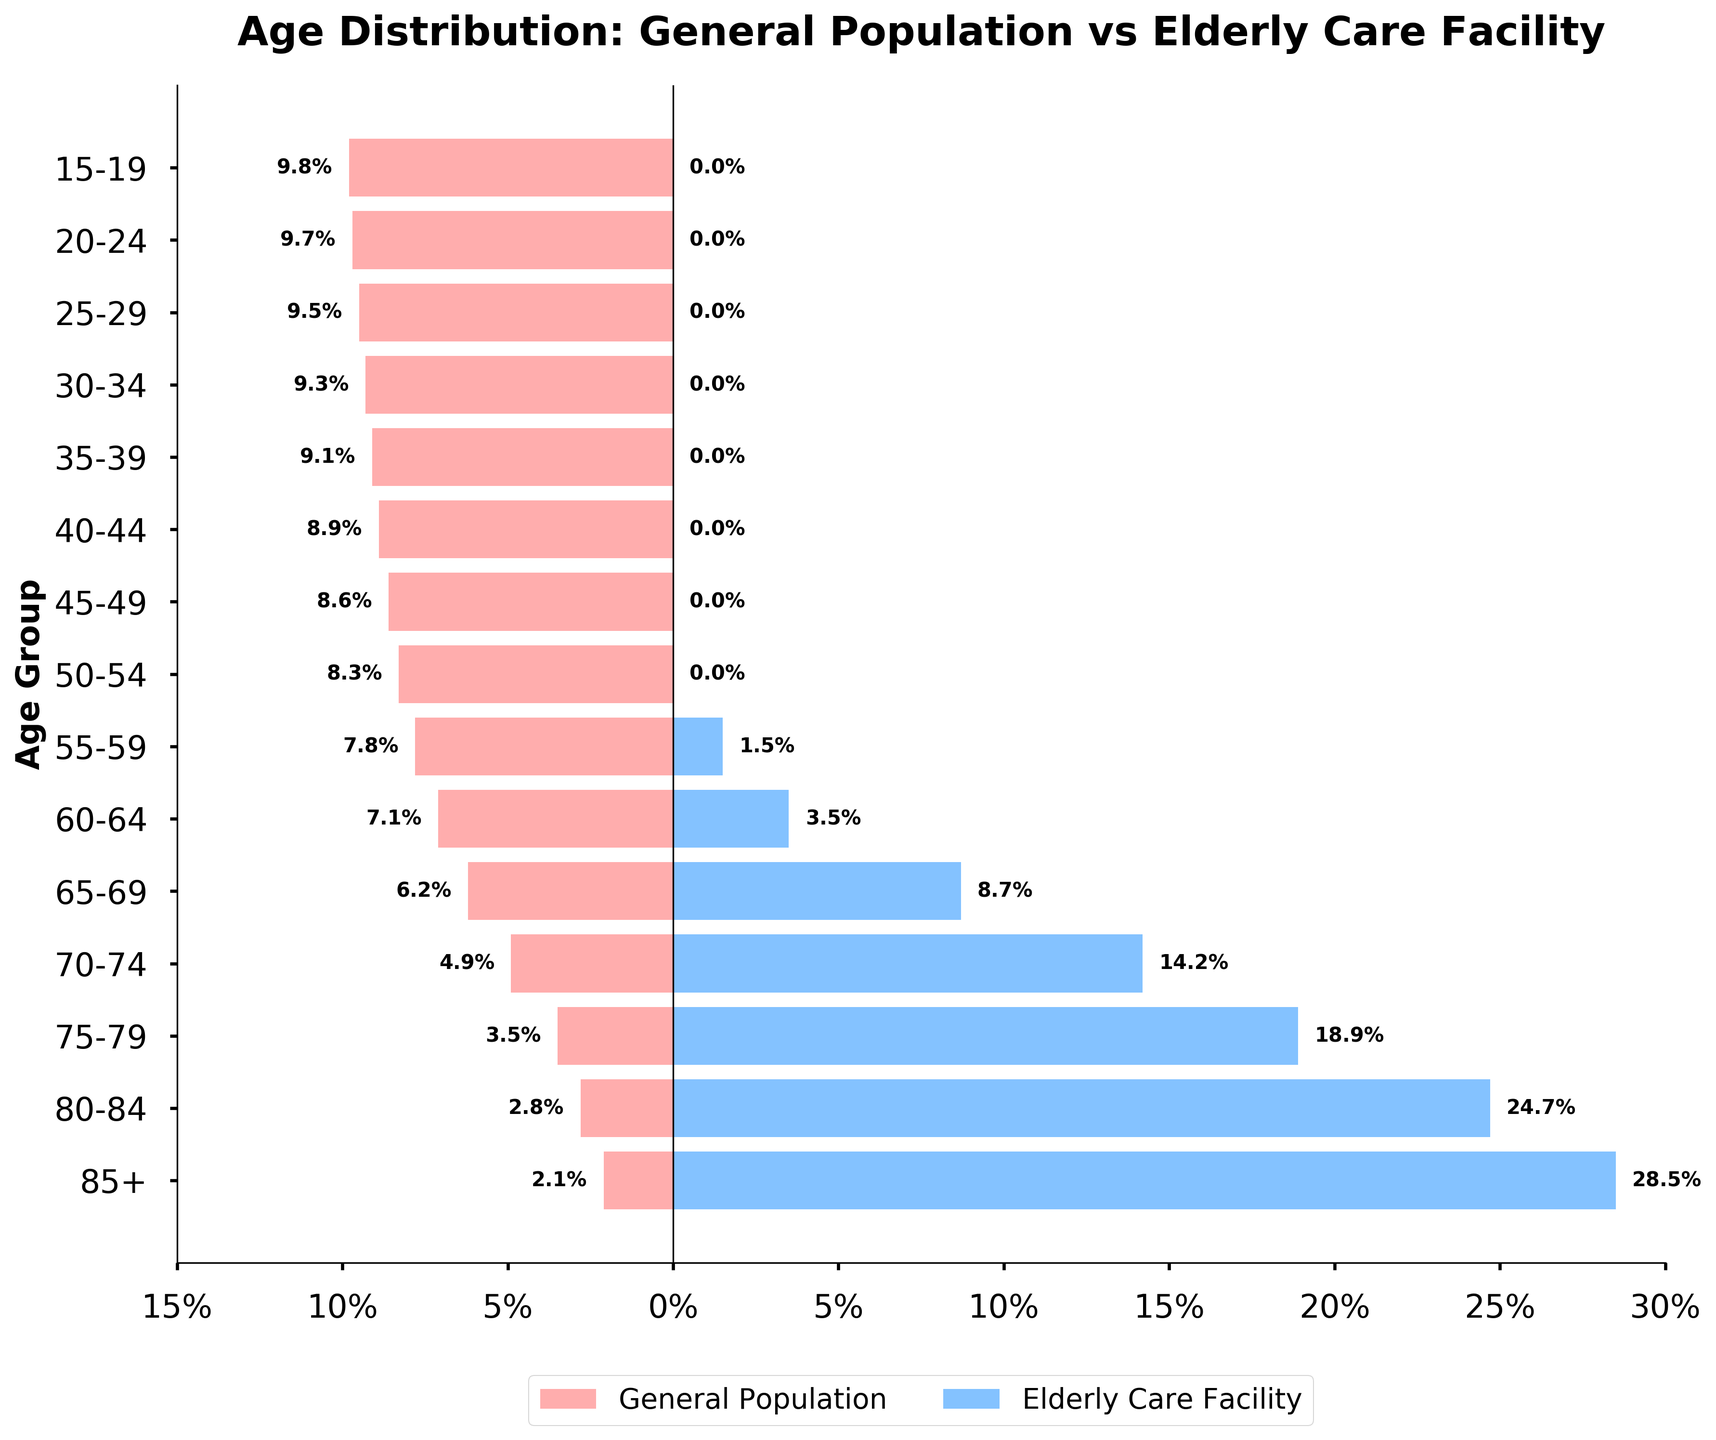What is the percentage of residents aged 85+ in the elderly care facility? Look at the bar corresponding to the age group 85+ and read its value on the x-axis. The bar extends to 28.5%.
Answer: 28.5% How does the percentage of the general population aged 80-84 compare to that in the elderly care facility? Compare the lengths of the bars for the 80-84 age group on both sides of the plot. The general population bar extends to -2.8% and the elderly care facility extends to 24.7%.
Answer: 2.8% vs 24.7% What age group shows the largest difference in percentage between the general population and the elderly care facility? Calculate the difference for each age group by subtracting the general population percentage from the elderly care facility percentage, then find the maximum difference. It is largest for the 85+ group (28.5% - 2.1% = 26.4%).
Answer: 85+ How many age groups have a 0% representation in the elderly care facility? Count the number of age groups where the bar on the right side of the plot is absent (0%).
Answer: 9 What age group among the elderly care facility residents is least represented? Identify the shortest bar on the right side of the plot. The age group 55-59 has a bar extending only to 1.5%.
Answer: 55-59 Which age group has the highest percentage in the general population? Identify the age group with the longest bar on the left side of the plot. The group 15-19 has the highest percentage at 9.8%.
Answer: 15-19 What is the total percentage of residents aged 75+ in the elderly care facility? Add the percentages of the age groups 75-79, 80-84, and 85+ from the elderly care facility data. The sum is 18.9% + 24.7% + 28.5% = 72.1%.
Answer: 72.1% How many total age groups are analyzed in the figure? Count the number of distinct age groups listed on the y-axis.
Answer: 15 What is the title of the plot? Read the title text at the top of the figure.
Answer: Age Distribution: General Population vs Elderly Care Facility Which side of the plot represents the general population? Look for the label indicating which side each category occupies. The label for the general population is on the left side.
Answer: Left 